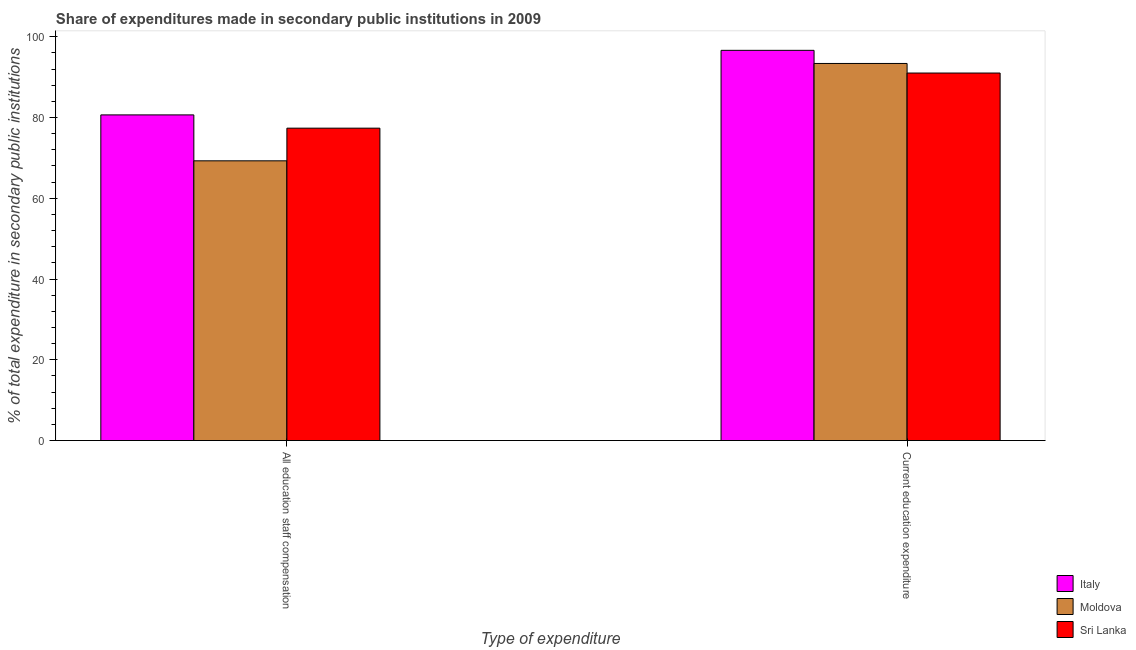How many groups of bars are there?
Make the answer very short. 2. Are the number of bars on each tick of the X-axis equal?
Offer a terse response. Yes. How many bars are there on the 1st tick from the left?
Make the answer very short. 3. What is the label of the 2nd group of bars from the left?
Your answer should be very brief. Current education expenditure. What is the expenditure in staff compensation in Sri Lanka?
Offer a very short reply. 77.35. Across all countries, what is the maximum expenditure in staff compensation?
Offer a terse response. 80.64. Across all countries, what is the minimum expenditure in education?
Give a very brief answer. 91. In which country was the expenditure in staff compensation maximum?
Give a very brief answer. Italy. In which country was the expenditure in staff compensation minimum?
Offer a very short reply. Moldova. What is the total expenditure in education in the graph?
Keep it short and to the point. 281. What is the difference between the expenditure in staff compensation in Italy and that in Sri Lanka?
Your response must be concise. 3.28. What is the difference between the expenditure in education in Italy and the expenditure in staff compensation in Sri Lanka?
Offer a terse response. 19.27. What is the average expenditure in education per country?
Your answer should be compact. 93.67. What is the difference between the expenditure in staff compensation and expenditure in education in Italy?
Keep it short and to the point. -15.99. In how many countries, is the expenditure in staff compensation greater than 48 %?
Offer a terse response. 3. What is the ratio of the expenditure in education in Sri Lanka to that in Moldova?
Make the answer very short. 0.97. Is the expenditure in education in Moldova less than that in Sri Lanka?
Provide a succinct answer. No. In how many countries, is the expenditure in staff compensation greater than the average expenditure in staff compensation taken over all countries?
Your answer should be very brief. 2. What does the 2nd bar from the left in Current education expenditure represents?
Offer a very short reply. Moldova. What is the difference between two consecutive major ticks on the Y-axis?
Your answer should be very brief. 20. Does the graph contain any zero values?
Keep it short and to the point. No. Does the graph contain grids?
Your answer should be very brief. No. How are the legend labels stacked?
Provide a succinct answer. Vertical. What is the title of the graph?
Ensure brevity in your answer.  Share of expenditures made in secondary public institutions in 2009. Does "Vanuatu" appear as one of the legend labels in the graph?
Make the answer very short. No. What is the label or title of the X-axis?
Your answer should be very brief. Type of expenditure. What is the label or title of the Y-axis?
Provide a short and direct response. % of total expenditure in secondary public institutions. What is the % of total expenditure in secondary public institutions in Italy in All education staff compensation?
Keep it short and to the point. 80.64. What is the % of total expenditure in secondary public institutions of Moldova in All education staff compensation?
Your answer should be compact. 69.27. What is the % of total expenditure in secondary public institutions in Sri Lanka in All education staff compensation?
Make the answer very short. 77.35. What is the % of total expenditure in secondary public institutions of Italy in Current education expenditure?
Offer a terse response. 96.62. What is the % of total expenditure in secondary public institutions of Moldova in Current education expenditure?
Give a very brief answer. 93.37. What is the % of total expenditure in secondary public institutions of Sri Lanka in Current education expenditure?
Make the answer very short. 91. Across all Type of expenditure, what is the maximum % of total expenditure in secondary public institutions in Italy?
Offer a terse response. 96.62. Across all Type of expenditure, what is the maximum % of total expenditure in secondary public institutions of Moldova?
Keep it short and to the point. 93.37. Across all Type of expenditure, what is the maximum % of total expenditure in secondary public institutions in Sri Lanka?
Offer a terse response. 91. Across all Type of expenditure, what is the minimum % of total expenditure in secondary public institutions in Italy?
Your response must be concise. 80.64. Across all Type of expenditure, what is the minimum % of total expenditure in secondary public institutions in Moldova?
Keep it short and to the point. 69.27. Across all Type of expenditure, what is the minimum % of total expenditure in secondary public institutions in Sri Lanka?
Offer a very short reply. 77.35. What is the total % of total expenditure in secondary public institutions of Italy in the graph?
Keep it short and to the point. 177.26. What is the total % of total expenditure in secondary public institutions in Moldova in the graph?
Provide a short and direct response. 162.64. What is the total % of total expenditure in secondary public institutions of Sri Lanka in the graph?
Offer a terse response. 168.35. What is the difference between the % of total expenditure in secondary public institutions of Italy in All education staff compensation and that in Current education expenditure?
Provide a succinct answer. -15.99. What is the difference between the % of total expenditure in secondary public institutions of Moldova in All education staff compensation and that in Current education expenditure?
Offer a terse response. -24.11. What is the difference between the % of total expenditure in secondary public institutions of Sri Lanka in All education staff compensation and that in Current education expenditure?
Your answer should be very brief. -13.65. What is the difference between the % of total expenditure in secondary public institutions of Italy in All education staff compensation and the % of total expenditure in secondary public institutions of Moldova in Current education expenditure?
Provide a short and direct response. -12.74. What is the difference between the % of total expenditure in secondary public institutions of Italy in All education staff compensation and the % of total expenditure in secondary public institutions of Sri Lanka in Current education expenditure?
Make the answer very short. -10.37. What is the difference between the % of total expenditure in secondary public institutions of Moldova in All education staff compensation and the % of total expenditure in secondary public institutions of Sri Lanka in Current education expenditure?
Your answer should be compact. -21.74. What is the average % of total expenditure in secondary public institutions in Italy per Type of expenditure?
Make the answer very short. 88.63. What is the average % of total expenditure in secondary public institutions of Moldova per Type of expenditure?
Offer a terse response. 81.32. What is the average % of total expenditure in secondary public institutions in Sri Lanka per Type of expenditure?
Make the answer very short. 84.18. What is the difference between the % of total expenditure in secondary public institutions of Italy and % of total expenditure in secondary public institutions of Moldova in All education staff compensation?
Provide a succinct answer. 11.37. What is the difference between the % of total expenditure in secondary public institutions of Italy and % of total expenditure in secondary public institutions of Sri Lanka in All education staff compensation?
Your answer should be very brief. 3.29. What is the difference between the % of total expenditure in secondary public institutions in Moldova and % of total expenditure in secondary public institutions in Sri Lanka in All education staff compensation?
Your answer should be very brief. -8.09. What is the difference between the % of total expenditure in secondary public institutions in Italy and % of total expenditure in secondary public institutions in Moldova in Current education expenditure?
Make the answer very short. 3.25. What is the difference between the % of total expenditure in secondary public institutions in Italy and % of total expenditure in secondary public institutions in Sri Lanka in Current education expenditure?
Make the answer very short. 5.62. What is the difference between the % of total expenditure in secondary public institutions in Moldova and % of total expenditure in secondary public institutions in Sri Lanka in Current education expenditure?
Offer a very short reply. 2.37. What is the ratio of the % of total expenditure in secondary public institutions in Italy in All education staff compensation to that in Current education expenditure?
Offer a very short reply. 0.83. What is the ratio of the % of total expenditure in secondary public institutions of Moldova in All education staff compensation to that in Current education expenditure?
Provide a short and direct response. 0.74. What is the ratio of the % of total expenditure in secondary public institutions of Sri Lanka in All education staff compensation to that in Current education expenditure?
Your answer should be compact. 0.85. What is the difference between the highest and the second highest % of total expenditure in secondary public institutions in Italy?
Offer a terse response. 15.99. What is the difference between the highest and the second highest % of total expenditure in secondary public institutions of Moldova?
Give a very brief answer. 24.11. What is the difference between the highest and the second highest % of total expenditure in secondary public institutions of Sri Lanka?
Give a very brief answer. 13.65. What is the difference between the highest and the lowest % of total expenditure in secondary public institutions in Italy?
Provide a short and direct response. 15.99. What is the difference between the highest and the lowest % of total expenditure in secondary public institutions in Moldova?
Give a very brief answer. 24.11. What is the difference between the highest and the lowest % of total expenditure in secondary public institutions in Sri Lanka?
Ensure brevity in your answer.  13.65. 